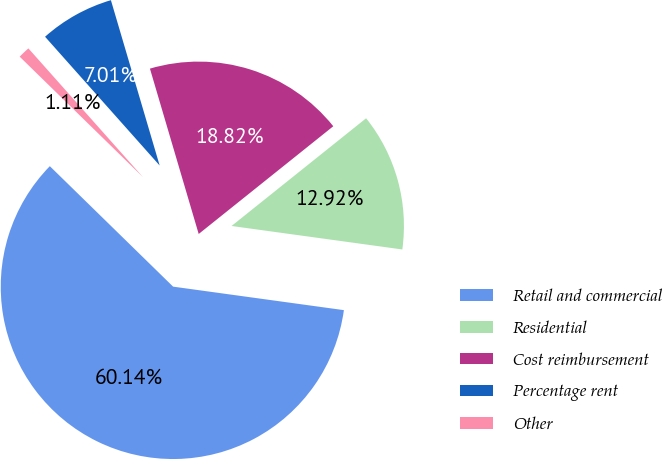<chart> <loc_0><loc_0><loc_500><loc_500><pie_chart><fcel>Retail and commercial<fcel>Residential<fcel>Cost reimbursement<fcel>Percentage rent<fcel>Other<nl><fcel>60.14%<fcel>12.92%<fcel>18.82%<fcel>7.01%<fcel>1.11%<nl></chart> 